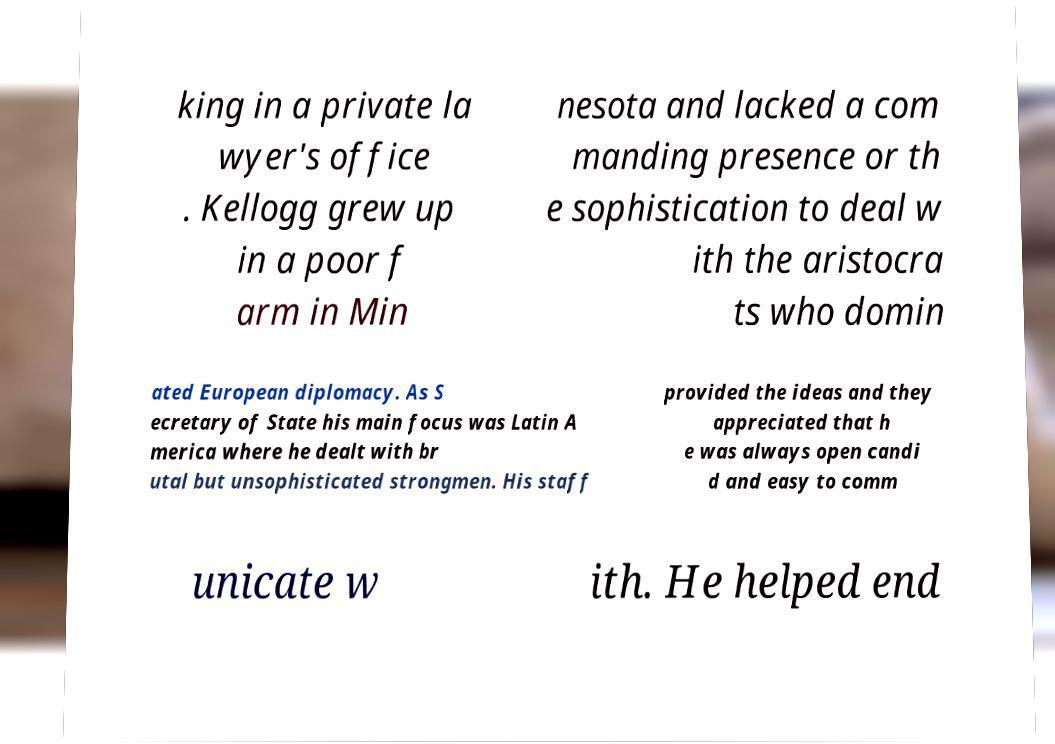Can you accurately transcribe the text from the provided image for me? king in a private la wyer's office . Kellogg grew up in a poor f arm in Min nesota and lacked a com manding presence or th e sophistication to deal w ith the aristocra ts who domin ated European diplomacy. As S ecretary of State his main focus was Latin A merica where he dealt with br utal but unsophisticated strongmen. His staff provided the ideas and they appreciated that h e was always open candi d and easy to comm unicate w ith. He helped end 